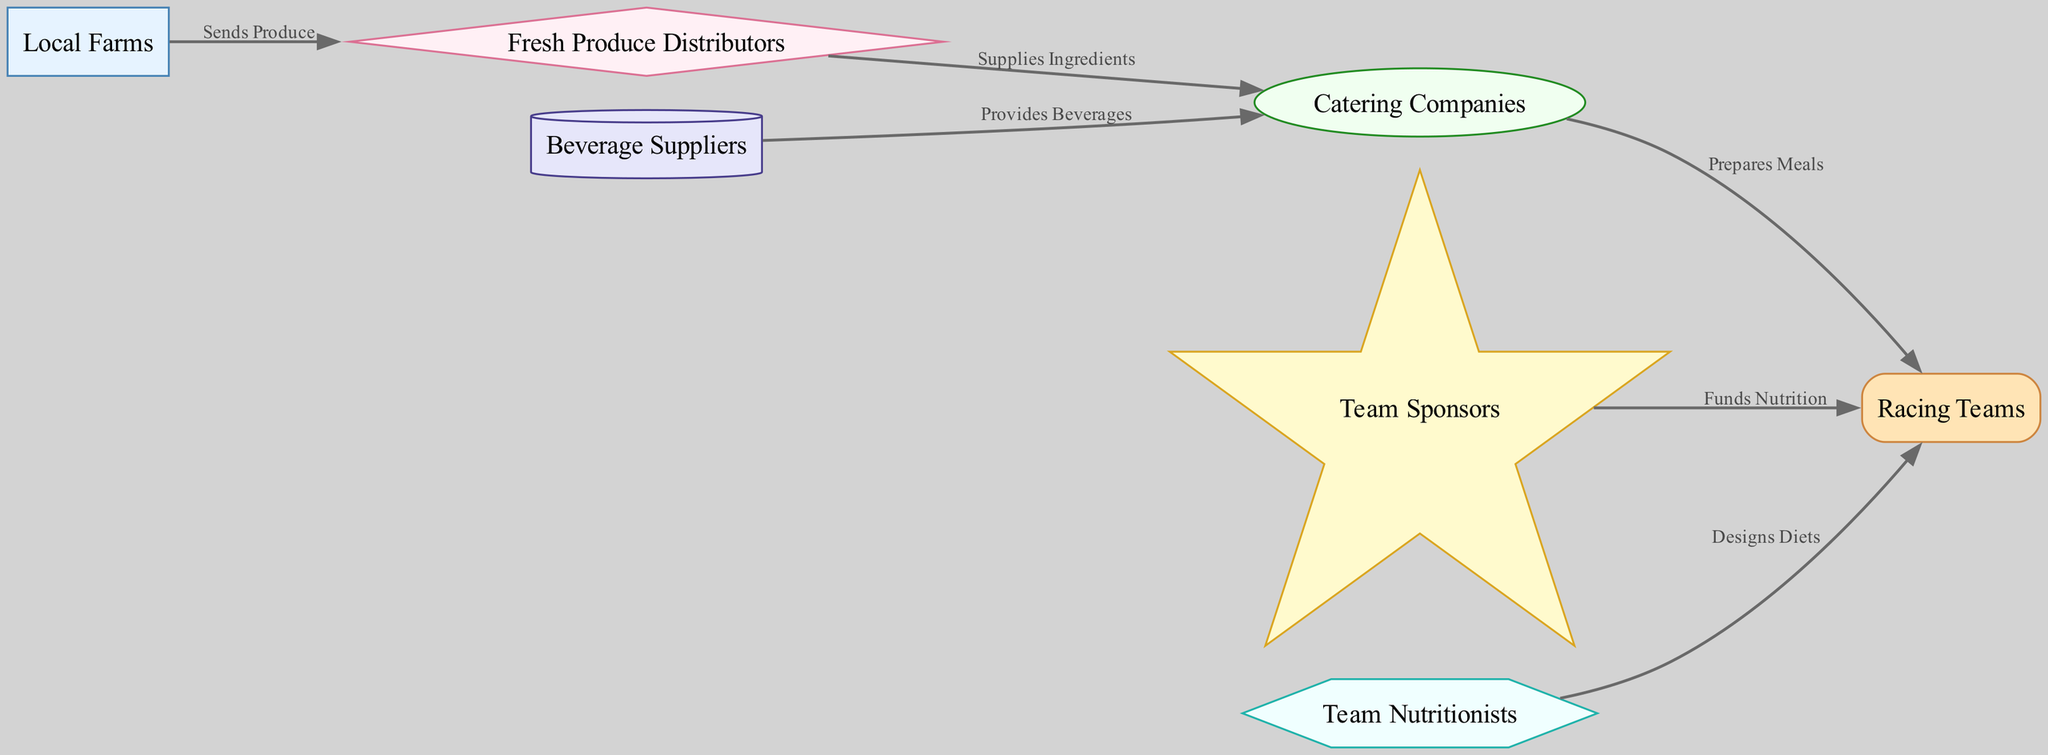What is the source of fresh produce? The diagram shows that fresh produce comes from Local Farms, as indicated by the direct flow from "farmer" to "distributor."
Answer: Local Farms Who supplies ingredients to catering companies? According to the diagram, Fresh Produce Distributors provide ingredients, as represented by the edge from "distributor" to "caterers."
Answer: Fresh Produce Distributors How many nodes are involved in the flow of refreshments? The diagram lists seven distinct nodes: Local Farms, Fresh Produce Distributors, Catering Companies, Racing Teams, Beverage Suppliers, Team Sponsors, and Team Nutritionists, totaling to seven nodes.
Answer: Seven What role do beverage companies play in this diagram? Beverage Suppliers provide beverages to Catering Companies, as indicated by the directed edge from "beverage_companies" to "caterers."
Answer: Provides Beverages What is the relationship between team sponsors and racing teams? Team Sponsors fund the nutrition for the Racing Teams, as shown by the edge from "sponsors" to "teams" labeled "Funds Nutrition."
Answer: Funds Nutrition Which entity designs diets for racing teams? The diagram clearly shows that Team Nutritionists are responsible for designing diets for Racing Teams, indicated by the edge from "nutritionists" to "teams."
Answer: Team Nutritionists What does the catering company deliver to racing teams? Catering Companies prepare meals for Racing Teams, as shown by the directed edge connecting "caterers" to "teams."
Answer: Prepares Meals Which node receives produce directly from local farms? Fresh Produce Distributors are the node that receives produce directly from Local Farms, as indicated by the edge labeled "Sends Produce."
Answer: Fresh Produce Distributors What is the flow of snacks from farmers to racing teams? The flow starts at Local Farms that send produce to Fresh Produce Distributors, who then supply ingredients to Catering Companies that prepare meals for Racing Teams.
Answer: Local Farms → Fresh Produce Distributors → Catering Companies → Racing Teams 